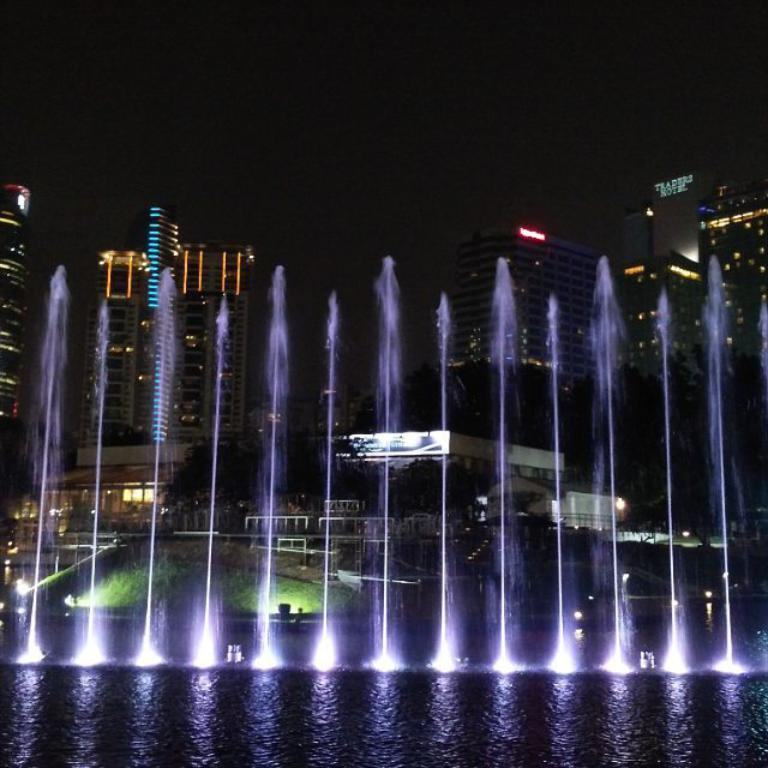What time of day is depicted in the image? The image is a night view. What structures can be seen in the image? There are buildings in the image. What is located in front of the buildings? There is a fountain in front of the buildings. What type of shoe can be seen on the fountain in the image? There are no shoes present in the image, and the fountain is not associated with any footwear. 